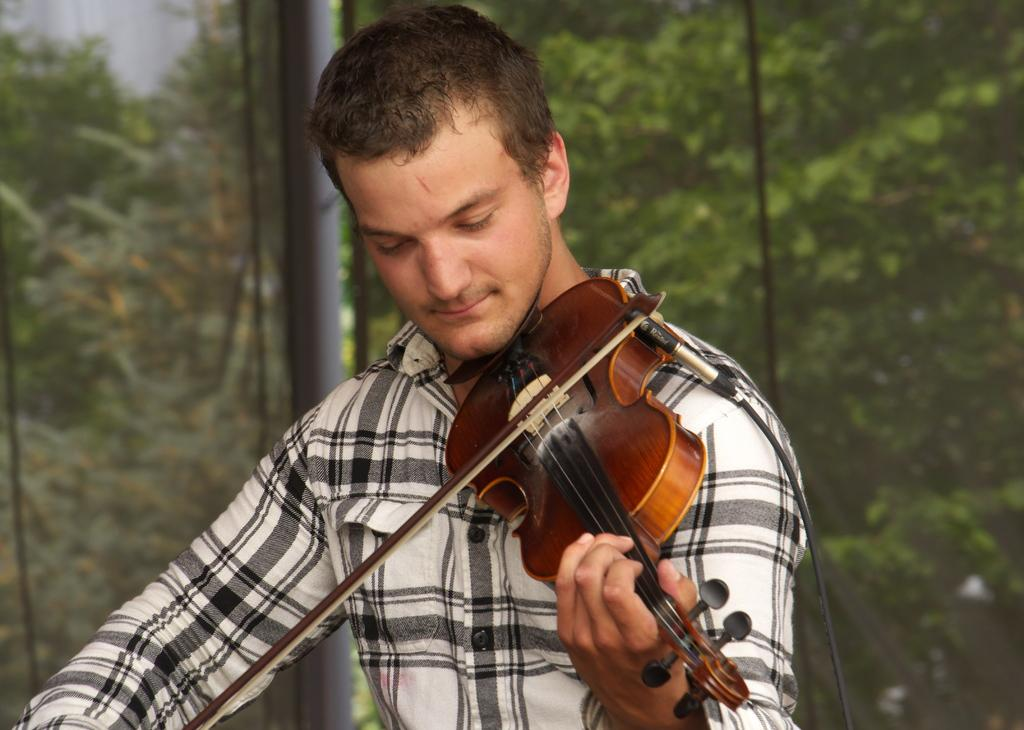Who is the main subject in the image? There is a man in the image. What is the man wearing? The man is wearing a white and black shirt. What is the man holding in the image? The man is holding a guitar. What is the man doing with the guitar? The man is playing the guitar. What can be seen in the background of the image? There are trees visible in the background of the image. What type of yam is being cooked in the image? There is: There is no yam present in the image; it features a man playing a guitar with trees in the background. 